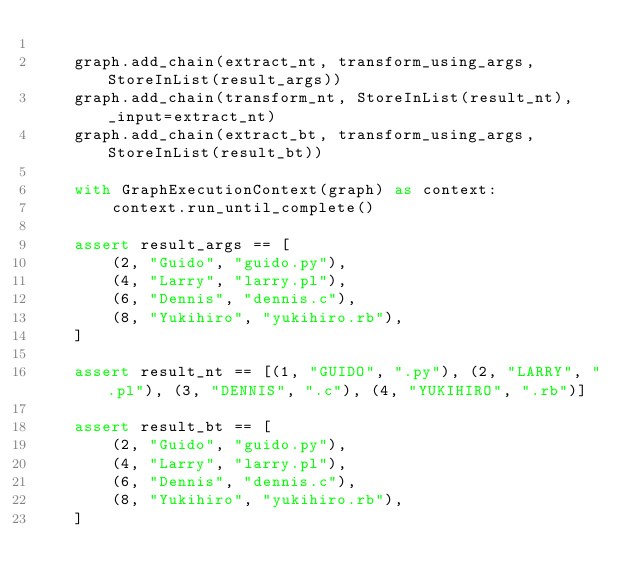<code> <loc_0><loc_0><loc_500><loc_500><_Python_>
    graph.add_chain(extract_nt, transform_using_args, StoreInList(result_args))
    graph.add_chain(transform_nt, StoreInList(result_nt), _input=extract_nt)
    graph.add_chain(extract_bt, transform_using_args, StoreInList(result_bt))

    with GraphExecutionContext(graph) as context:
        context.run_until_complete()

    assert result_args == [
        (2, "Guido", "guido.py"),
        (4, "Larry", "larry.pl"),
        (6, "Dennis", "dennis.c"),
        (8, "Yukihiro", "yukihiro.rb"),
    ]

    assert result_nt == [(1, "GUIDO", ".py"), (2, "LARRY", ".pl"), (3, "DENNIS", ".c"), (4, "YUKIHIRO", ".rb")]

    assert result_bt == [
        (2, "Guido", "guido.py"),
        (4, "Larry", "larry.pl"),
        (6, "Dennis", "dennis.c"),
        (8, "Yukihiro", "yukihiro.rb"),
    ]
</code> 